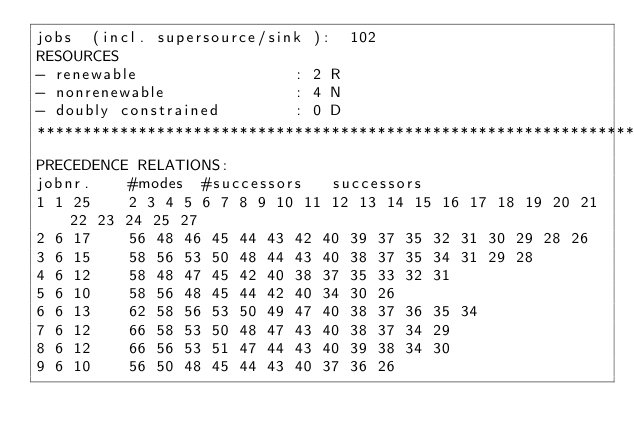Convert code to text. <code><loc_0><loc_0><loc_500><loc_500><_ObjectiveC_>jobs  (incl. supersource/sink ):	102
RESOURCES
- renewable                 : 2 R
- nonrenewable              : 4 N
- doubly constrained        : 0 D
************************************************************************
PRECEDENCE RELATIONS:
jobnr.    #modes  #successors   successors
1	1	25		2 3 4 5 6 7 8 9 10 11 12 13 14 15 16 17 18 19 20 21 22 23 24 25 27 
2	6	17		56 48 46 45 44 43 42 40 39 37 35 32 31 30 29 28 26 
3	6	15		58 56 53 50 48 44 43 40 38 37 35 34 31 29 28 
4	6	12		58 48 47 45 42 40 38 37 35 33 32 31 
5	6	10		58 56 48 45 44 42 40 34 30 26 
6	6	13		62 58 56 53 50 49 47 40 38 37 36 35 34 
7	6	12		66 58 53 50 48 47 43 40 38 37 34 29 
8	6	12		66 56 53 51 47 44 43 40 39 38 34 30 
9	6	10		56 50 48 45 44 43 40 37 36 26 </code> 